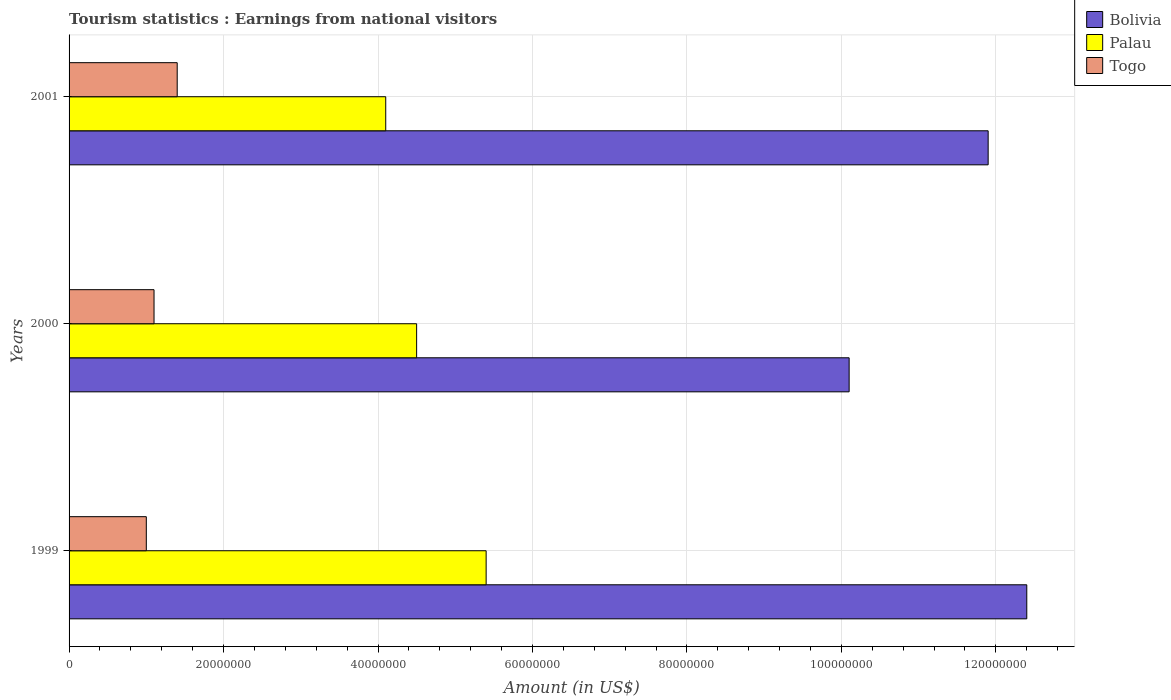How many different coloured bars are there?
Provide a succinct answer. 3. What is the label of the 2nd group of bars from the top?
Offer a terse response. 2000. What is the earnings from national visitors in Bolivia in 2000?
Ensure brevity in your answer.  1.01e+08. Across all years, what is the maximum earnings from national visitors in Bolivia?
Make the answer very short. 1.24e+08. Across all years, what is the minimum earnings from national visitors in Palau?
Offer a terse response. 4.10e+07. In which year was the earnings from national visitors in Palau maximum?
Provide a short and direct response. 1999. In which year was the earnings from national visitors in Palau minimum?
Ensure brevity in your answer.  2001. What is the total earnings from national visitors in Bolivia in the graph?
Your response must be concise. 3.44e+08. What is the difference between the earnings from national visitors in Togo in 1999 and that in 2001?
Offer a very short reply. -4.00e+06. What is the difference between the earnings from national visitors in Togo in 2000 and the earnings from national visitors in Palau in 1999?
Make the answer very short. -4.30e+07. What is the average earnings from national visitors in Bolivia per year?
Give a very brief answer. 1.15e+08. In the year 1999, what is the difference between the earnings from national visitors in Palau and earnings from national visitors in Togo?
Your answer should be very brief. 4.40e+07. In how many years, is the earnings from national visitors in Togo greater than 4000000 US$?
Your answer should be compact. 3. What is the ratio of the earnings from national visitors in Bolivia in 1999 to that in 2001?
Make the answer very short. 1.04. Is the difference between the earnings from national visitors in Palau in 2000 and 2001 greater than the difference between the earnings from national visitors in Togo in 2000 and 2001?
Provide a succinct answer. Yes. What is the difference between the highest and the lowest earnings from national visitors in Palau?
Offer a terse response. 1.30e+07. In how many years, is the earnings from national visitors in Bolivia greater than the average earnings from national visitors in Bolivia taken over all years?
Your answer should be very brief. 2. Is the sum of the earnings from national visitors in Bolivia in 1999 and 2001 greater than the maximum earnings from national visitors in Togo across all years?
Offer a terse response. Yes. What does the 2nd bar from the top in 2000 represents?
Your response must be concise. Palau. What does the 2nd bar from the bottom in 1999 represents?
Your answer should be very brief. Palau. How many years are there in the graph?
Make the answer very short. 3. What is the difference between two consecutive major ticks on the X-axis?
Give a very brief answer. 2.00e+07. Does the graph contain grids?
Provide a short and direct response. Yes. Where does the legend appear in the graph?
Give a very brief answer. Top right. How are the legend labels stacked?
Ensure brevity in your answer.  Vertical. What is the title of the graph?
Give a very brief answer. Tourism statistics : Earnings from national visitors. Does "Fiji" appear as one of the legend labels in the graph?
Provide a short and direct response. No. What is the Amount (in US$) of Bolivia in 1999?
Provide a succinct answer. 1.24e+08. What is the Amount (in US$) in Palau in 1999?
Your response must be concise. 5.40e+07. What is the Amount (in US$) of Togo in 1999?
Your answer should be compact. 1.00e+07. What is the Amount (in US$) of Bolivia in 2000?
Make the answer very short. 1.01e+08. What is the Amount (in US$) in Palau in 2000?
Your answer should be very brief. 4.50e+07. What is the Amount (in US$) in Togo in 2000?
Give a very brief answer. 1.10e+07. What is the Amount (in US$) in Bolivia in 2001?
Ensure brevity in your answer.  1.19e+08. What is the Amount (in US$) of Palau in 2001?
Ensure brevity in your answer.  4.10e+07. What is the Amount (in US$) in Togo in 2001?
Offer a terse response. 1.40e+07. Across all years, what is the maximum Amount (in US$) of Bolivia?
Your answer should be compact. 1.24e+08. Across all years, what is the maximum Amount (in US$) in Palau?
Give a very brief answer. 5.40e+07. Across all years, what is the maximum Amount (in US$) of Togo?
Make the answer very short. 1.40e+07. Across all years, what is the minimum Amount (in US$) in Bolivia?
Ensure brevity in your answer.  1.01e+08. Across all years, what is the minimum Amount (in US$) in Palau?
Your answer should be compact. 4.10e+07. What is the total Amount (in US$) in Bolivia in the graph?
Provide a short and direct response. 3.44e+08. What is the total Amount (in US$) of Palau in the graph?
Give a very brief answer. 1.40e+08. What is the total Amount (in US$) of Togo in the graph?
Give a very brief answer. 3.50e+07. What is the difference between the Amount (in US$) in Bolivia in 1999 and that in 2000?
Provide a short and direct response. 2.30e+07. What is the difference between the Amount (in US$) of Palau in 1999 and that in 2000?
Ensure brevity in your answer.  9.00e+06. What is the difference between the Amount (in US$) of Bolivia in 1999 and that in 2001?
Your response must be concise. 5.00e+06. What is the difference between the Amount (in US$) of Palau in 1999 and that in 2001?
Offer a terse response. 1.30e+07. What is the difference between the Amount (in US$) in Bolivia in 2000 and that in 2001?
Ensure brevity in your answer.  -1.80e+07. What is the difference between the Amount (in US$) of Palau in 2000 and that in 2001?
Provide a succinct answer. 4.00e+06. What is the difference between the Amount (in US$) in Togo in 2000 and that in 2001?
Your answer should be compact. -3.00e+06. What is the difference between the Amount (in US$) of Bolivia in 1999 and the Amount (in US$) of Palau in 2000?
Offer a very short reply. 7.90e+07. What is the difference between the Amount (in US$) of Bolivia in 1999 and the Amount (in US$) of Togo in 2000?
Offer a very short reply. 1.13e+08. What is the difference between the Amount (in US$) of Palau in 1999 and the Amount (in US$) of Togo in 2000?
Provide a succinct answer. 4.30e+07. What is the difference between the Amount (in US$) in Bolivia in 1999 and the Amount (in US$) in Palau in 2001?
Your answer should be compact. 8.30e+07. What is the difference between the Amount (in US$) of Bolivia in 1999 and the Amount (in US$) of Togo in 2001?
Keep it short and to the point. 1.10e+08. What is the difference between the Amount (in US$) of Palau in 1999 and the Amount (in US$) of Togo in 2001?
Ensure brevity in your answer.  4.00e+07. What is the difference between the Amount (in US$) in Bolivia in 2000 and the Amount (in US$) in Palau in 2001?
Your answer should be compact. 6.00e+07. What is the difference between the Amount (in US$) of Bolivia in 2000 and the Amount (in US$) of Togo in 2001?
Provide a short and direct response. 8.70e+07. What is the difference between the Amount (in US$) in Palau in 2000 and the Amount (in US$) in Togo in 2001?
Keep it short and to the point. 3.10e+07. What is the average Amount (in US$) of Bolivia per year?
Keep it short and to the point. 1.15e+08. What is the average Amount (in US$) of Palau per year?
Offer a terse response. 4.67e+07. What is the average Amount (in US$) in Togo per year?
Provide a succinct answer. 1.17e+07. In the year 1999, what is the difference between the Amount (in US$) in Bolivia and Amount (in US$) in Palau?
Your response must be concise. 7.00e+07. In the year 1999, what is the difference between the Amount (in US$) in Bolivia and Amount (in US$) in Togo?
Give a very brief answer. 1.14e+08. In the year 1999, what is the difference between the Amount (in US$) of Palau and Amount (in US$) of Togo?
Give a very brief answer. 4.40e+07. In the year 2000, what is the difference between the Amount (in US$) of Bolivia and Amount (in US$) of Palau?
Your answer should be very brief. 5.60e+07. In the year 2000, what is the difference between the Amount (in US$) in Bolivia and Amount (in US$) in Togo?
Your response must be concise. 9.00e+07. In the year 2000, what is the difference between the Amount (in US$) of Palau and Amount (in US$) of Togo?
Your answer should be very brief. 3.40e+07. In the year 2001, what is the difference between the Amount (in US$) of Bolivia and Amount (in US$) of Palau?
Provide a short and direct response. 7.80e+07. In the year 2001, what is the difference between the Amount (in US$) of Bolivia and Amount (in US$) of Togo?
Your response must be concise. 1.05e+08. In the year 2001, what is the difference between the Amount (in US$) of Palau and Amount (in US$) of Togo?
Offer a terse response. 2.70e+07. What is the ratio of the Amount (in US$) in Bolivia in 1999 to that in 2000?
Ensure brevity in your answer.  1.23. What is the ratio of the Amount (in US$) in Togo in 1999 to that in 2000?
Ensure brevity in your answer.  0.91. What is the ratio of the Amount (in US$) of Bolivia in 1999 to that in 2001?
Offer a terse response. 1.04. What is the ratio of the Amount (in US$) in Palau in 1999 to that in 2001?
Ensure brevity in your answer.  1.32. What is the ratio of the Amount (in US$) in Bolivia in 2000 to that in 2001?
Your answer should be compact. 0.85. What is the ratio of the Amount (in US$) in Palau in 2000 to that in 2001?
Keep it short and to the point. 1.1. What is the ratio of the Amount (in US$) of Togo in 2000 to that in 2001?
Your answer should be compact. 0.79. What is the difference between the highest and the second highest Amount (in US$) of Bolivia?
Offer a very short reply. 5.00e+06. What is the difference between the highest and the second highest Amount (in US$) of Palau?
Offer a terse response. 9.00e+06. What is the difference between the highest and the lowest Amount (in US$) in Bolivia?
Provide a short and direct response. 2.30e+07. What is the difference between the highest and the lowest Amount (in US$) of Palau?
Offer a terse response. 1.30e+07. What is the difference between the highest and the lowest Amount (in US$) of Togo?
Provide a short and direct response. 4.00e+06. 